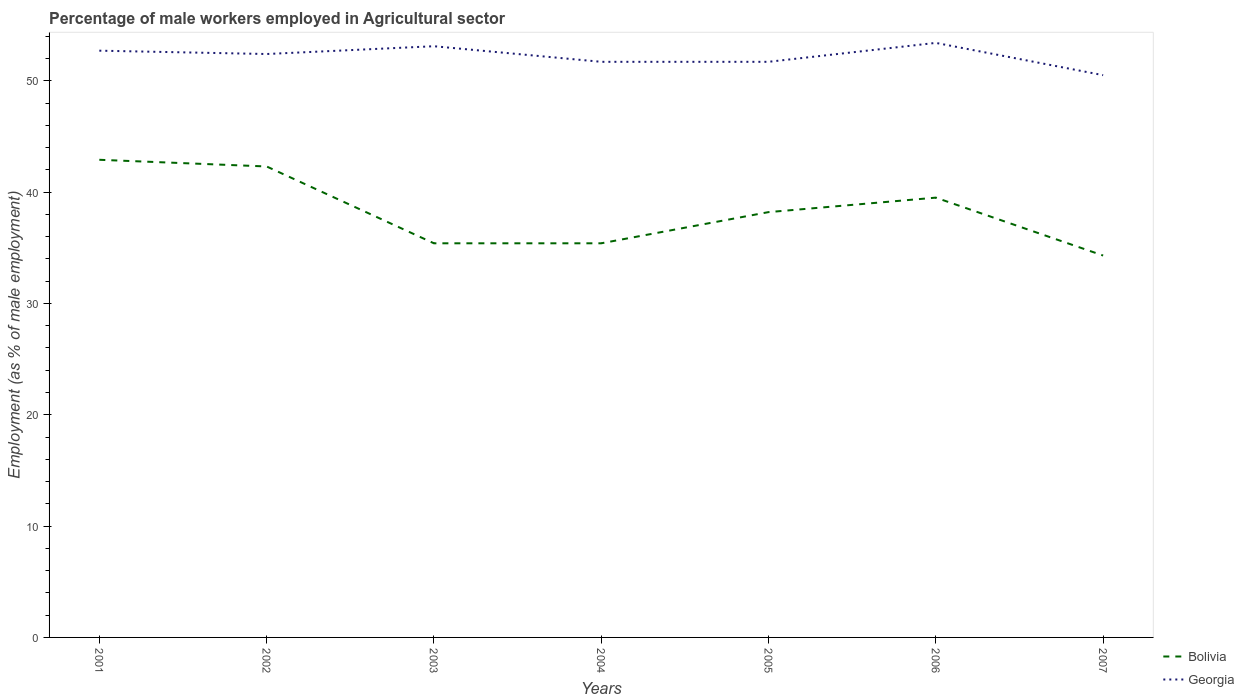Is the number of lines equal to the number of legend labels?
Offer a terse response. Yes. Across all years, what is the maximum percentage of male workers employed in Agricultural sector in Georgia?
Offer a terse response. 50.5. What is the total percentage of male workers employed in Agricultural sector in Bolivia in the graph?
Provide a short and direct response. -2.8. What is the difference between the highest and the second highest percentage of male workers employed in Agricultural sector in Bolivia?
Make the answer very short. 8.6. What is the difference between the highest and the lowest percentage of male workers employed in Agricultural sector in Georgia?
Keep it short and to the point. 4. Is the percentage of male workers employed in Agricultural sector in Bolivia strictly greater than the percentage of male workers employed in Agricultural sector in Georgia over the years?
Provide a short and direct response. Yes. How many years are there in the graph?
Provide a short and direct response. 7. What is the difference between two consecutive major ticks on the Y-axis?
Give a very brief answer. 10. Does the graph contain grids?
Your response must be concise. No. How are the legend labels stacked?
Make the answer very short. Vertical. What is the title of the graph?
Offer a terse response. Percentage of male workers employed in Agricultural sector. Does "San Marino" appear as one of the legend labels in the graph?
Your response must be concise. No. What is the label or title of the X-axis?
Make the answer very short. Years. What is the label or title of the Y-axis?
Give a very brief answer. Employment (as % of male employment). What is the Employment (as % of male employment) in Bolivia in 2001?
Keep it short and to the point. 42.9. What is the Employment (as % of male employment) in Georgia in 2001?
Offer a very short reply. 52.7. What is the Employment (as % of male employment) of Bolivia in 2002?
Provide a succinct answer. 42.3. What is the Employment (as % of male employment) of Georgia in 2002?
Your answer should be very brief. 52.4. What is the Employment (as % of male employment) of Bolivia in 2003?
Your answer should be compact. 35.4. What is the Employment (as % of male employment) in Georgia in 2003?
Your response must be concise. 53.1. What is the Employment (as % of male employment) of Bolivia in 2004?
Offer a terse response. 35.4. What is the Employment (as % of male employment) in Georgia in 2004?
Ensure brevity in your answer.  51.7. What is the Employment (as % of male employment) in Bolivia in 2005?
Keep it short and to the point. 38.2. What is the Employment (as % of male employment) in Georgia in 2005?
Your answer should be compact. 51.7. What is the Employment (as % of male employment) of Bolivia in 2006?
Your answer should be very brief. 39.5. What is the Employment (as % of male employment) of Georgia in 2006?
Make the answer very short. 53.4. What is the Employment (as % of male employment) of Bolivia in 2007?
Give a very brief answer. 34.3. What is the Employment (as % of male employment) in Georgia in 2007?
Your answer should be very brief. 50.5. Across all years, what is the maximum Employment (as % of male employment) in Bolivia?
Provide a short and direct response. 42.9. Across all years, what is the maximum Employment (as % of male employment) in Georgia?
Ensure brevity in your answer.  53.4. Across all years, what is the minimum Employment (as % of male employment) in Bolivia?
Provide a succinct answer. 34.3. Across all years, what is the minimum Employment (as % of male employment) in Georgia?
Provide a short and direct response. 50.5. What is the total Employment (as % of male employment) in Bolivia in the graph?
Give a very brief answer. 268. What is the total Employment (as % of male employment) in Georgia in the graph?
Your answer should be very brief. 365.5. What is the difference between the Employment (as % of male employment) of Bolivia in 2001 and that in 2002?
Keep it short and to the point. 0.6. What is the difference between the Employment (as % of male employment) in Georgia in 2001 and that in 2003?
Your response must be concise. -0.4. What is the difference between the Employment (as % of male employment) of Bolivia in 2001 and that in 2004?
Provide a short and direct response. 7.5. What is the difference between the Employment (as % of male employment) of Georgia in 2001 and that in 2004?
Provide a succinct answer. 1. What is the difference between the Employment (as % of male employment) of Bolivia in 2001 and that in 2005?
Keep it short and to the point. 4.7. What is the difference between the Employment (as % of male employment) in Georgia in 2001 and that in 2005?
Make the answer very short. 1. What is the difference between the Employment (as % of male employment) of Bolivia in 2001 and that in 2006?
Give a very brief answer. 3.4. What is the difference between the Employment (as % of male employment) of Bolivia in 2001 and that in 2007?
Provide a succinct answer. 8.6. What is the difference between the Employment (as % of male employment) in Bolivia in 2002 and that in 2003?
Give a very brief answer. 6.9. What is the difference between the Employment (as % of male employment) in Georgia in 2002 and that in 2003?
Offer a very short reply. -0.7. What is the difference between the Employment (as % of male employment) in Bolivia in 2002 and that in 2006?
Offer a very short reply. 2.8. What is the difference between the Employment (as % of male employment) of Bolivia in 2002 and that in 2007?
Offer a very short reply. 8. What is the difference between the Employment (as % of male employment) in Bolivia in 2003 and that in 2004?
Ensure brevity in your answer.  0. What is the difference between the Employment (as % of male employment) in Georgia in 2003 and that in 2006?
Offer a terse response. -0.3. What is the difference between the Employment (as % of male employment) in Georgia in 2003 and that in 2007?
Provide a short and direct response. 2.6. What is the difference between the Employment (as % of male employment) in Bolivia in 2004 and that in 2005?
Offer a very short reply. -2.8. What is the difference between the Employment (as % of male employment) of Georgia in 2004 and that in 2005?
Make the answer very short. 0. What is the difference between the Employment (as % of male employment) of Georgia in 2004 and that in 2006?
Offer a very short reply. -1.7. What is the difference between the Employment (as % of male employment) in Bolivia in 2004 and that in 2007?
Make the answer very short. 1.1. What is the difference between the Employment (as % of male employment) in Georgia in 2005 and that in 2007?
Provide a succinct answer. 1.2. What is the difference between the Employment (as % of male employment) in Georgia in 2006 and that in 2007?
Give a very brief answer. 2.9. What is the difference between the Employment (as % of male employment) in Bolivia in 2001 and the Employment (as % of male employment) in Georgia in 2002?
Your answer should be compact. -9.5. What is the difference between the Employment (as % of male employment) in Bolivia in 2001 and the Employment (as % of male employment) in Georgia in 2003?
Keep it short and to the point. -10.2. What is the difference between the Employment (as % of male employment) in Bolivia in 2001 and the Employment (as % of male employment) in Georgia in 2005?
Ensure brevity in your answer.  -8.8. What is the difference between the Employment (as % of male employment) of Bolivia in 2001 and the Employment (as % of male employment) of Georgia in 2006?
Provide a short and direct response. -10.5. What is the difference between the Employment (as % of male employment) in Bolivia in 2001 and the Employment (as % of male employment) in Georgia in 2007?
Your answer should be compact. -7.6. What is the difference between the Employment (as % of male employment) in Bolivia in 2002 and the Employment (as % of male employment) in Georgia in 2003?
Provide a succinct answer. -10.8. What is the difference between the Employment (as % of male employment) in Bolivia in 2002 and the Employment (as % of male employment) in Georgia in 2004?
Your answer should be compact. -9.4. What is the difference between the Employment (as % of male employment) of Bolivia in 2002 and the Employment (as % of male employment) of Georgia in 2005?
Offer a very short reply. -9.4. What is the difference between the Employment (as % of male employment) of Bolivia in 2002 and the Employment (as % of male employment) of Georgia in 2006?
Give a very brief answer. -11.1. What is the difference between the Employment (as % of male employment) of Bolivia in 2003 and the Employment (as % of male employment) of Georgia in 2004?
Provide a succinct answer. -16.3. What is the difference between the Employment (as % of male employment) of Bolivia in 2003 and the Employment (as % of male employment) of Georgia in 2005?
Your answer should be compact. -16.3. What is the difference between the Employment (as % of male employment) in Bolivia in 2003 and the Employment (as % of male employment) in Georgia in 2006?
Your response must be concise. -18. What is the difference between the Employment (as % of male employment) of Bolivia in 2003 and the Employment (as % of male employment) of Georgia in 2007?
Your answer should be compact. -15.1. What is the difference between the Employment (as % of male employment) in Bolivia in 2004 and the Employment (as % of male employment) in Georgia in 2005?
Your answer should be very brief. -16.3. What is the difference between the Employment (as % of male employment) of Bolivia in 2004 and the Employment (as % of male employment) of Georgia in 2007?
Provide a short and direct response. -15.1. What is the difference between the Employment (as % of male employment) in Bolivia in 2005 and the Employment (as % of male employment) in Georgia in 2006?
Your answer should be very brief. -15.2. What is the difference between the Employment (as % of male employment) in Bolivia in 2006 and the Employment (as % of male employment) in Georgia in 2007?
Provide a succinct answer. -11. What is the average Employment (as % of male employment) in Bolivia per year?
Offer a very short reply. 38.29. What is the average Employment (as % of male employment) in Georgia per year?
Your answer should be very brief. 52.21. In the year 2001, what is the difference between the Employment (as % of male employment) in Bolivia and Employment (as % of male employment) in Georgia?
Provide a short and direct response. -9.8. In the year 2002, what is the difference between the Employment (as % of male employment) in Bolivia and Employment (as % of male employment) in Georgia?
Ensure brevity in your answer.  -10.1. In the year 2003, what is the difference between the Employment (as % of male employment) of Bolivia and Employment (as % of male employment) of Georgia?
Offer a very short reply. -17.7. In the year 2004, what is the difference between the Employment (as % of male employment) in Bolivia and Employment (as % of male employment) in Georgia?
Ensure brevity in your answer.  -16.3. In the year 2005, what is the difference between the Employment (as % of male employment) in Bolivia and Employment (as % of male employment) in Georgia?
Ensure brevity in your answer.  -13.5. In the year 2007, what is the difference between the Employment (as % of male employment) in Bolivia and Employment (as % of male employment) in Georgia?
Make the answer very short. -16.2. What is the ratio of the Employment (as % of male employment) in Bolivia in 2001 to that in 2002?
Your response must be concise. 1.01. What is the ratio of the Employment (as % of male employment) of Bolivia in 2001 to that in 2003?
Your answer should be compact. 1.21. What is the ratio of the Employment (as % of male employment) of Bolivia in 2001 to that in 2004?
Keep it short and to the point. 1.21. What is the ratio of the Employment (as % of male employment) in Georgia in 2001 to that in 2004?
Give a very brief answer. 1.02. What is the ratio of the Employment (as % of male employment) in Bolivia in 2001 to that in 2005?
Offer a very short reply. 1.12. What is the ratio of the Employment (as % of male employment) of Georgia in 2001 to that in 2005?
Your response must be concise. 1.02. What is the ratio of the Employment (as % of male employment) in Bolivia in 2001 to that in 2006?
Your answer should be compact. 1.09. What is the ratio of the Employment (as % of male employment) of Georgia in 2001 to that in 2006?
Make the answer very short. 0.99. What is the ratio of the Employment (as % of male employment) of Bolivia in 2001 to that in 2007?
Keep it short and to the point. 1.25. What is the ratio of the Employment (as % of male employment) in Georgia in 2001 to that in 2007?
Provide a succinct answer. 1.04. What is the ratio of the Employment (as % of male employment) in Bolivia in 2002 to that in 2003?
Give a very brief answer. 1.19. What is the ratio of the Employment (as % of male employment) in Bolivia in 2002 to that in 2004?
Offer a terse response. 1.19. What is the ratio of the Employment (as % of male employment) of Georgia in 2002 to that in 2004?
Provide a succinct answer. 1.01. What is the ratio of the Employment (as % of male employment) of Bolivia in 2002 to that in 2005?
Offer a terse response. 1.11. What is the ratio of the Employment (as % of male employment) in Georgia in 2002 to that in 2005?
Offer a very short reply. 1.01. What is the ratio of the Employment (as % of male employment) in Bolivia in 2002 to that in 2006?
Provide a succinct answer. 1.07. What is the ratio of the Employment (as % of male employment) of Georgia in 2002 to that in 2006?
Offer a terse response. 0.98. What is the ratio of the Employment (as % of male employment) in Bolivia in 2002 to that in 2007?
Provide a short and direct response. 1.23. What is the ratio of the Employment (as % of male employment) of Georgia in 2002 to that in 2007?
Your answer should be compact. 1.04. What is the ratio of the Employment (as % of male employment) in Bolivia in 2003 to that in 2004?
Keep it short and to the point. 1. What is the ratio of the Employment (as % of male employment) of Georgia in 2003 to that in 2004?
Offer a very short reply. 1.03. What is the ratio of the Employment (as % of male employment) in Bolivia in 2003 to that in 2005?
Provide a short and direct response. 0.93. What is the ratio of the Employment (as % of male employment) in Georgia in 2003 to that in 2005?
Make the answer very short. 1.03. What is the ratio of the Employment (as % of male employment) of Bolivia in 2003 to that in 2006?
Provide a succinct answer. 0.9. What is the ratio of the Employment (as % of male employment) in Bolivia in 2003 to that in 2007?
Provide a succinct answer. 1.03. What is the ratio of the Employment (as % of male employment) of Georgia in 2003 to that in 2007?
Ensure brevity in your answer.  1.05. What is the ratio of the Employment (as % of male employment) in Bolivia in 2004 to that in 2005?
Make the answer very short. 0.93. What is the ratio of the Employment (as % of male employment) of Bolivia in 2004 to that in 2006?
Offer a very short reply. 0.9. What is the ratio of the Employment (as % of male employment) of Georgia in 2004 to that in 2006?
Ensure brevity in your answer.  0.97. What is the ratio of the Employment (as % of male employment) of Bolivia in 2004 to that in 2007?
Keep it short and to the point. 1.03. What is the ratio of the Employment (as % of male employment) of Georgia in 2004 to that in 2007?
Your response must be concise. 1.02. What is the ratio of the Employment (as % of male employment) in Bolivia in 2005 to that in 2006?
Offer a terse response. 0.97. What is the ratio of the Employment (as % of male employment) in Georgia in 2005 to that in 2006?
Your response must be concise. 0.97. What is the ratio of the Employment (as % of male employment) of Bolivia in 2005 to that in 2007?
Provide a succinct answer. 1.11. What is the ratio of the Employment (as % of male employment) of Georgia in 2005 to that in 2007?
Provide a short and direct response. 1.02. What is the ratio of the Employment (as % of male employment) in Bolivia in 2006 to that in 2007?
Provide a short and direct response. 1.15. What is the ratio of the Employment (as % of male employment) in Georgia in 2006 to that in 2007?
Your answer should be very brief. 1.06. What is the difference between the highest and the second highest Employment (as % of male employment) in Georgia?
Offer a very short reply. 0.3. 